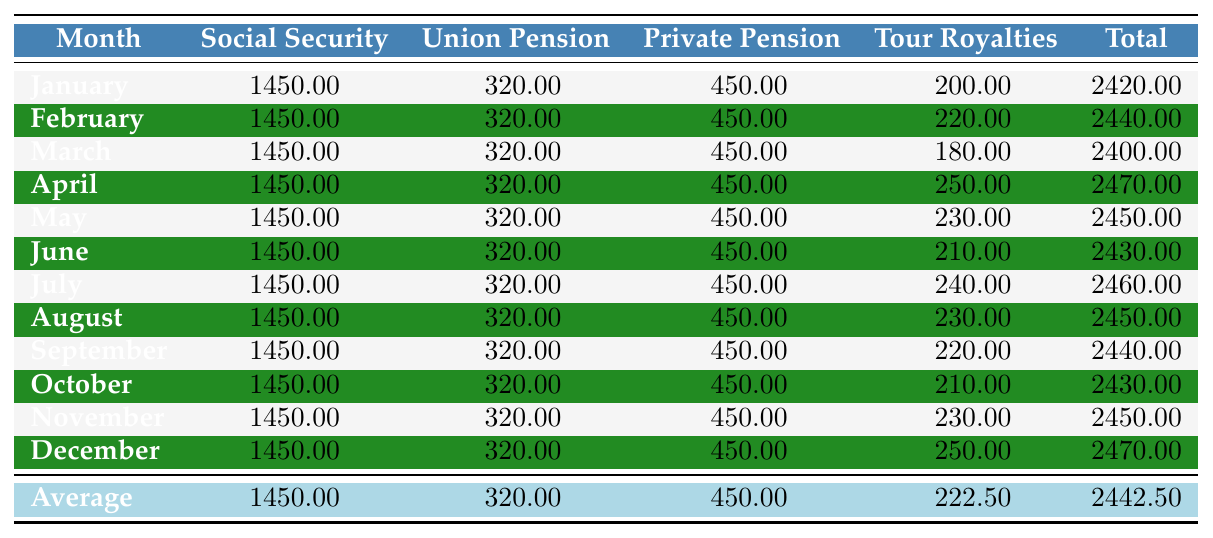What is the total Social Security income for April? The table shows a specific value for April under the Social Security column. The value listed is 1450.00.
Answer: 1450.00 What was the Tour Royalties income for March? Looking at the March row in the Tour Royalties column, the income listed is 180.00.
Answer: 180.00 How much did I earn in total income in July? The total income for July is shown in the Total column of the table, which is 2460.00.
Answer: 2460.00 What is the average Tour Royalties income across all months? To find the average, add all Tour Royalties incomes: (200 + 220 + 180 + 250 + 230 + 210 + 240 + 230 + 220 + 210 + 230 + 250) = 2520. Divide this by 12 months: 2520 / 12 = 210.00.
Answer: 210.00 Did my total income ever exceed 2500.00 in any month? Checking the Total column, the highest values do not exceed 2470.00 in any month. Therefore, the answer is no.
Answer: No What was the change in total income from February to March? The total for February is 2440.00 and for March is 2400.00. The change is subtracting the two amounts: 2400.00 - 2440.00 = -40.00 indicating a decrease.
Answer: -40.00 What is the sum of the Social Security income for the first half of the year (January to June)? Add the Social Security amounts for the first six months: (1450 + 1450 + 1450 + 1450 + 1450 + 1450) = 8700.00.
Answer: 8700.00 Which month had the highest total income? By comparing the total income figures in the Total column, April has the highest value at 2470.00.
Answer: April Is it true that the Private Pension income is consistent throughout the year? By examining the Private Pension column, the amounts are the same for all months at 450.00; thus, the answer is yes.
Answer: Yes 